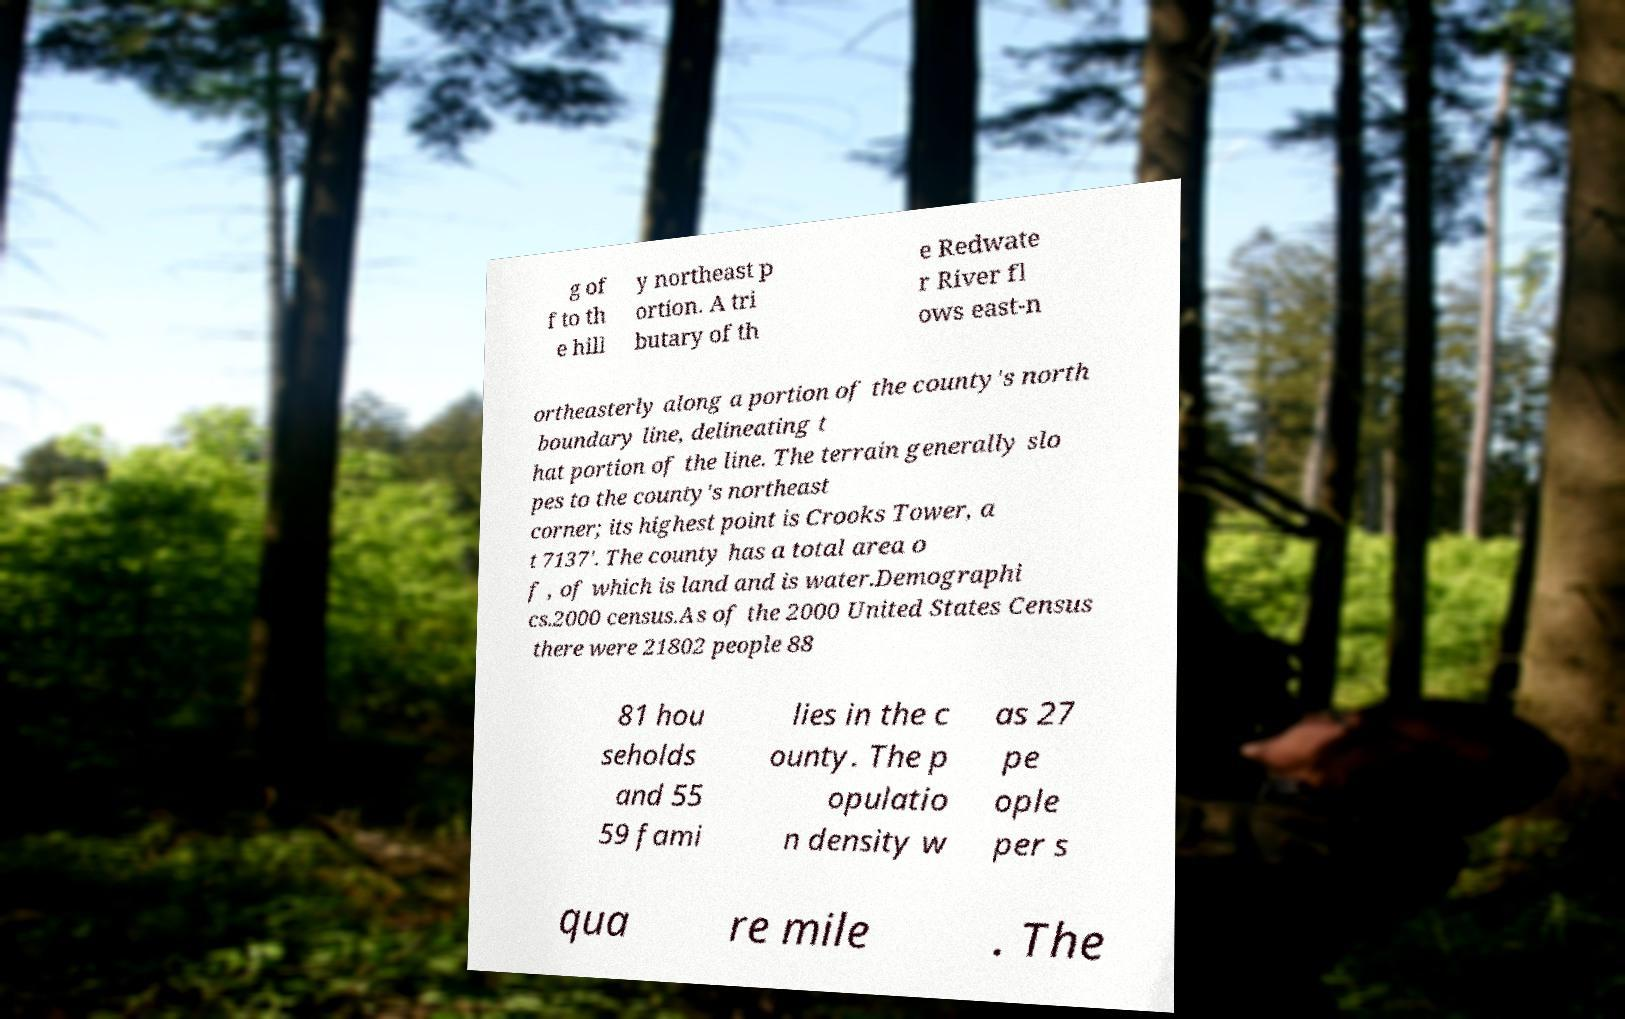Could you extract and type out the text from this image? g of f to th e hill y northeast p ortion. A tri butary of th e Redwate r River fl ows east-n ortheasterly along a portion of the county's north boundary line, delineating t hat portion of the line. The terrain generally slo pes to the county's northeast corner; its highest point is Crooks Tower, a t 7137'. The county has a total area o f , of which is land and is water.Demographi cs.2000 census.As of the 2000 United States Census there were 21802 people 88 81 hou seholds and 55 59 fami lies in the c ounty. The p opulatio n density w as 27 pe ople per s qua re mile . The 